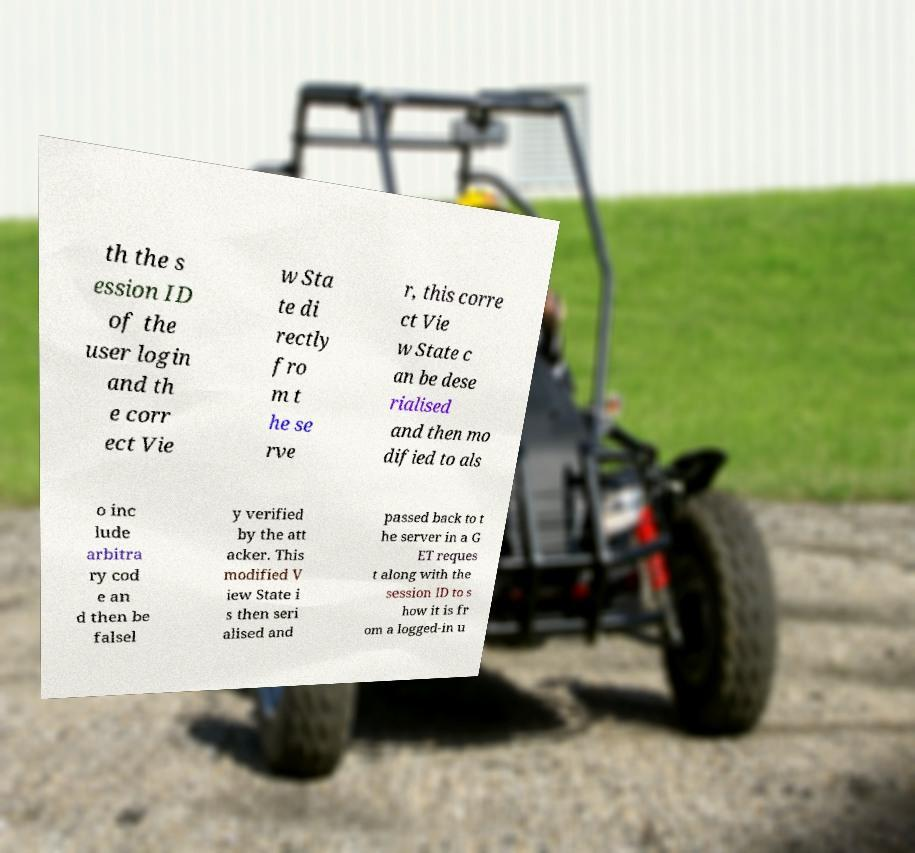I need the written content from this picture converted into text. Can you do that? th the s ession ID of the user login and th e corr ect Vie w Sta te di rectly fro m t he se rve r, this corre ct Vie w State c an be dese rialised and then mo dified to als o inc lude arbitra ry cod e an d then be falsel y verified by the att acker. This modified V iew State i s then seri alised and passed back to t he server in a G ET reques t along with the session ID to s how it is fr om a logged-in u 